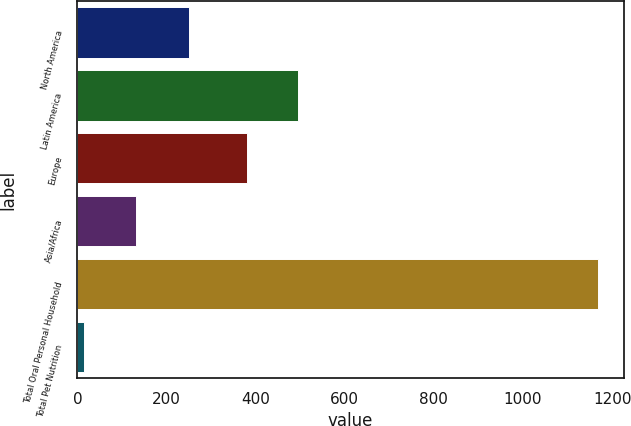<chart> <loc_0><loc_0><loc_500><loc_500><bar_chart><fcel>North America<fcel>Latin America<fcel>Europe<fcel>Asia/Africa<fcel>Total Oral Personal Household<fcel>Total Pet Nutrition<nl><fcel>250.1<fcel>495.18<fcel>379.9<fcel>130.28<fcel>1167.8<fcel>15<nl></chart> 